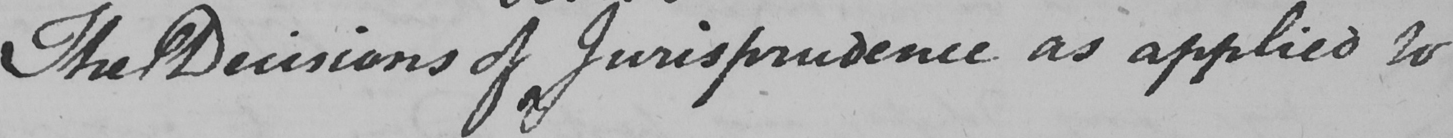What text is written in this handwritten line? The Decisions of Jurisprudence as applied to 